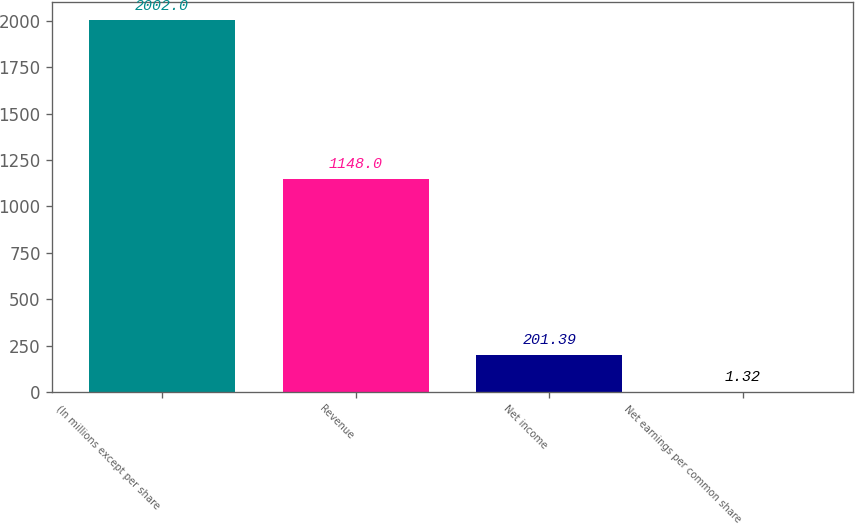Convert chart. <chart><loc_0><loc_0><loc_500><loc_500><bar_chart><fcel>(In millions except per share<fcel>Revenue<fcel>Net income<fcel>Net earnings per common share<nl><fcel>2002<fcel>1148<fcel>201.39<fcel>1.32<nl></chart> 